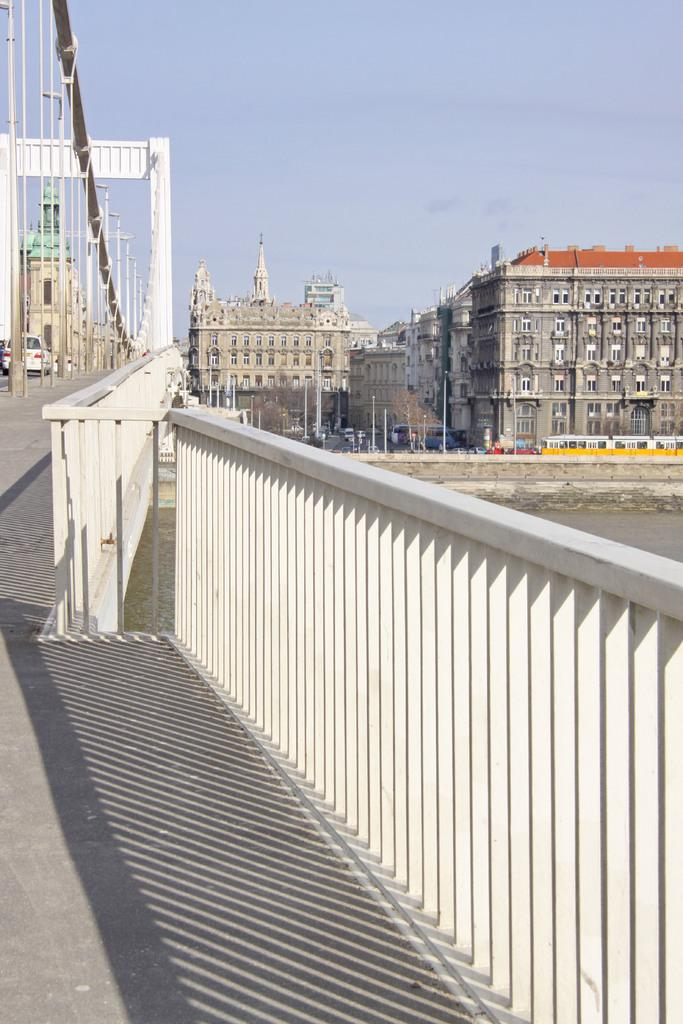What type of structure can be seen in the image? There is a bridge in the image. What else can be seen in the image besides the bridge? There are buildings, vehicles, poles, windows, trees, and a wall visible in the image. What is the background of the image? The sky is visible in the background of the image. What type of copper material is used to make the locket in the image? There is no locket present in the image, so it is not possible to determine the type of copper material used. 